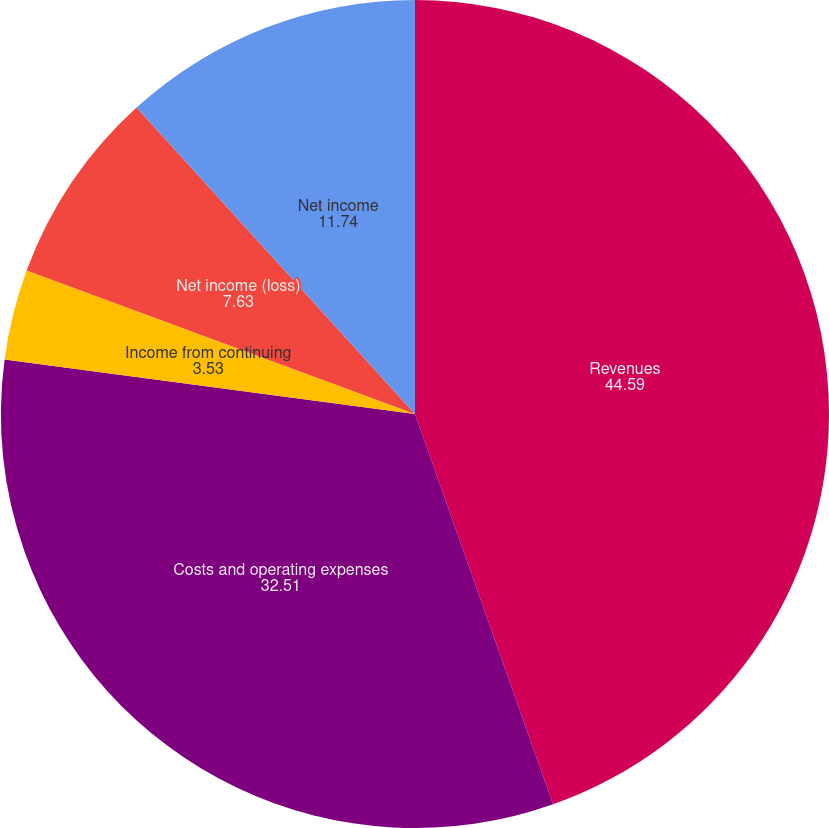Convert chart. <chart><loc_0><loc_0><loc_500><loc_500><pie_chart><fcel>Revenues<fcel>Costs and operating expenses<fcel>Income from continuing<fcel>Net income (loss)<fcel>Net income<nl><fcel>44.59%<fcel>32.51%<fcel>3.53%<fcel>7.63%<fcel>11.74%<nl></chart> 